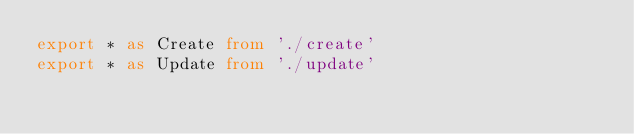Convert code to text. <code><loc_0><loc_0><loc_500><loc_500><_TypeScript_>export * as Create from './create'
export * as Update from './update'
</code> 